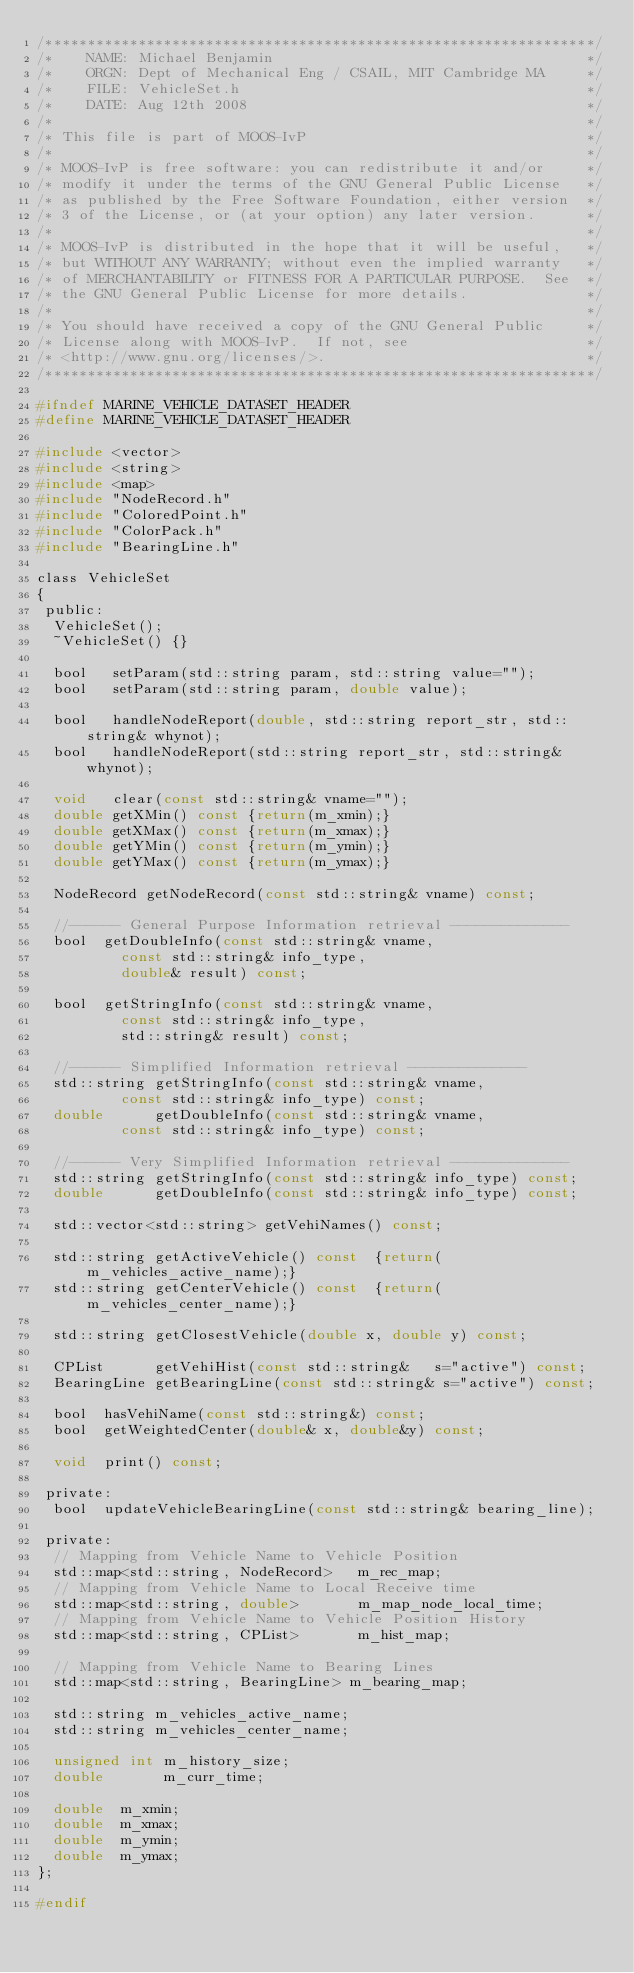<code> <loc_0><loc_0><loc_500><loc_500><_C_>/*****************************************************************/
/*    NAME: Michael Benjamin                                     */
/*    ORGN: Dept of Mechanical Eng / CSAIL, MIT Cambridge MA     */
/*    FILE: VehicleSet.h                                         */
/*    DATE: Aug 12th 2008                                        */
/*                                                               */
/* This file is part of MOOS-IvP                                 */
/*                                                               */
/* MOOS-IvP is free software: you can redistribute it and/or     */
/* modify it under the terms of the GNU General Public License   */
/* as published by the Free Software Foundation, either version  */
/* 3 of the License, or (at your option) any later version.      */
/*                                                               */
/* MOOS-IvP is distributed in the hope that it will be useful,   */
/* but WITHOUT ANY WARRANTY; without even the implied warranty   */
/* of MERCHANTABILITY or FITNESS FOR A PARTICULAR PURPOSE.  See  */
/* the GNU General Public License for more details.              */
/*                                                               */
/* You should have received a copy of the GNU General Public     */
/* License along with MOOS-IvP.  If not, see                     */
/* <http://www.gnu.org/licenses/>.                               */
/*****************************************************************/

#ifndef MARINE_VEHICLE_DATASET_HEADER
#define MARINE_VEHICLE_DATASET_HEADER

#include <vector>
#include <string>
#include <map>
#include "NodeRecord.h"
#include "ColoredPoint.h"
#include "ColorPack.h"
#include "BearingLine.h"

class VehicleSet
{
 public:
  VehicleSet();
  ~VehicleSet() {}
    
  bool   setParam(std::string param, std::string value="");
  bool   setParam(std::string param, double value);

  bool   handleNodeReport(double, std::string report_str, std::string& whynot);
  bool   handleNodeReport(std::string report_str, std::string& whynot);

  void   clear(const std::string& vname="");
  double getXMin() const {return(m_xmin);}
  double getXMax() const {return(m_xmax);}
  double getYMin() const {return(m_ymin);}
  double getYMax() const {return(m_ymax);}

  NodeRecord getNodeRecord(const std::string& vname) const;

  //------ General Purpose Information retrieval --------------
  bool  getDoubleInfo(const std::string& vname, 
		      const std::string& info_type, 
		      double& result) const;
  
  bool  getStringInfo(const std::string& vname, 
		      const std::string& info_type, 
		      std::string& result) const;

  //------ Simplified Information retrieval --------------
  std::string getStringInfo(const std::string& vname, 
			    const std::string& info_type) const;
  double      getDoubleInfo(const std::string& vname, 
			    const std::string& info_type) const;

  //------ Very Simplified Information retrieval --------------
  std::string getStringInfo(const std::string& info_type) const;
  double      getDoubleInfo(const std::string& info_type) const;

  std::vector<std::string> getVehiNames() const;

  std::string getActiveVehicle() const  {return(m_vehicles_active_name);}
  std::string getCenterVehicle() const  {return(m_vehicles_center_name);}

  std::string getClosestVehicle(double x, double y) const;
  
  CPList      getVehiHist(const std::string&   s="active") const;   
  BearingLine getBearingLine(const std::string& s="active") const;

  bool  hasVehiName(const std::string&) const;
  bool  getWeightedCenter(double& x, double&y) const;

  void  print() const;

 private:
  bool  updateVehicleBearingLine(const std::string& bearing_line); 

 private:
  // Mapping from Vehicle Name to Vehicle Position
  std::map<std::string, NodeRecord>   m_rec_map;
  // Mapping from Vehicle Name to Local Receive time
  std::map<std::string, double>       m_map_node_local_time;
  // Mapping from Vehicle Name to Vehicle Position History
  std::map<std::string, CPList>       m_hist_map;

  // Mapping from Vehicle Name to Bearing Lines
  std::map<std::string, BearingLine> m_bearing_map;

  std::string m_vehicles_active_name;
  std::string m_vehicles_center_name;

  unsigned int m_history_size;
  double       m_curr_time;

  double  m_xmin;
  double  m_xmax;
  double  m_ymin;
  double  m_ymax;
};

#endif 







</code> 